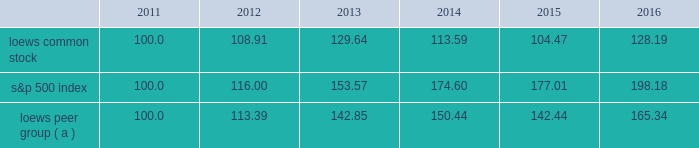Item 5 .
Market for the registrant 2019s common equity , related stockholder matters and issuer purchases of equity securities the following graph compares annual total return of our common stock , the standard & poor 2019s 500 composite stock index ( 201cs&p 500 index 201d ) and our peer group ( 201cloews peer group 201d ) for the five years ended december 31 , 2016 .
The graph assumes that the value of the investment in our common stock , the s&p 500 index and the loews peer group was $ 100 on december 31 , 2011 and that all dividends were reinvested. .
( a ) the loews peer group consists of the following companies that are industry competitors of our principal operating subsidiaries : chubb limited ( name change from ace limited after it acquired the chubb corporation on january 15 , 2016 ) , w.r .
Berkley corporation , the chubb corporation ( included through january 15 , 2016 when it was acquired by ace limited ) , energy transfer partners l.p. , ensco plc , the hartford financial services group , inc. , kinder morgan energy partners , l.p .
( included through november 26 , 2014 when it was acquired by kinder morgan inc. ) , noble corporation , spectra energy corp , transocean ltd .
And the travelers companies , inc .
Dividend information we have paid quarterly cash dividends in each year since 1967 .
Regular dividends of $ 0.0625 per share of loews common stock were paid in each calendar quarter of 2016 and 2015. .
What is the roi of an investment in loews common stock from 2011 to 2012? 
Computations: ((108.91 - 100) / 100)
Answer: 0.0891. 